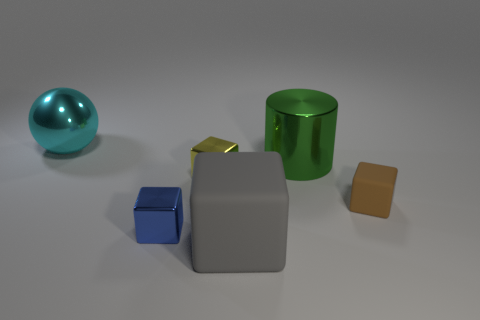Are there more tiny yellow cubes that are in front of the yellow object than metallic things?
Your answer should be very brief. No. Is there a green cylinder that is on the left side of the tiny blue metal object that is on the left side of the big metallic thing that is on the right side of the big cyan ball?
Offer a very short reply. No. Are there any big matte cubes in front of the tiny brown rubber object?
Keep it short and to the point. Yes. There is a cylinder that is made of the same material as the cyan ball; what is its size?
Your answer should be very brief. Large. There is a matte object that is in front of the rubber cube behind the matte block in front of the brown cube; how big is it?
Your response must be concise. Large. There is a metallic thing that is right of the small yellow thing; how big is it?
Your answer should be very brief. Large. What number of cyan things are either large objects or large cubes?
Make the answer very short. 1. Is there a metallic cylinder of the same size as the blue block?
Your answer should be very brief. No. There is a cyan sphere that is the same size as the metallic cylinder; what is its material?
Your response must be concise. Metal. Is the size of the rubber object that is behind the large gray matte block the same as the object left of the small blue shiny cube?
Provide a succinct answer. No. 